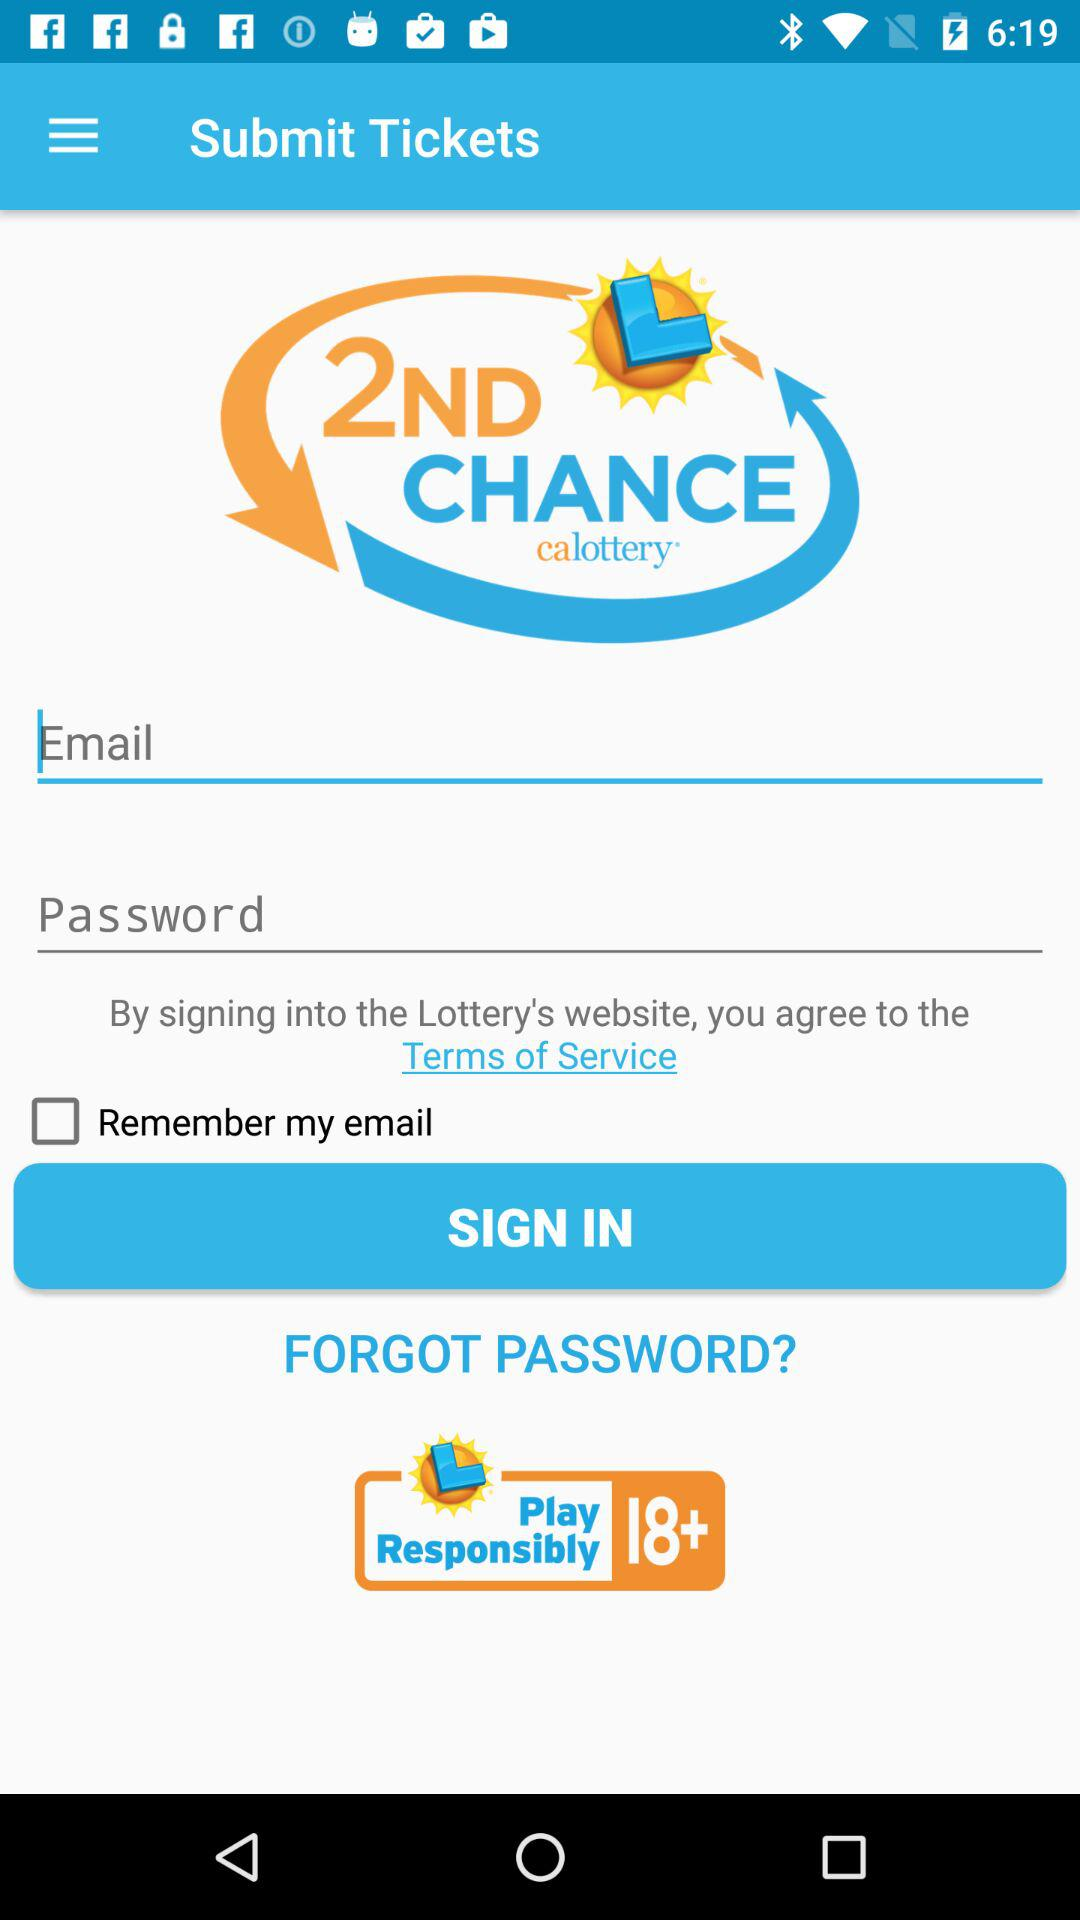How many input fields are there for login?
Answer the question using a single word or phrase. 2 